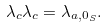Convert formula to latex. <formula><loc_0><loc_0><loc_500><loc_500>\lambda _ { c } \lambda _ { c } = \lambda _ { a , 0 _ { S } } .</formula> 